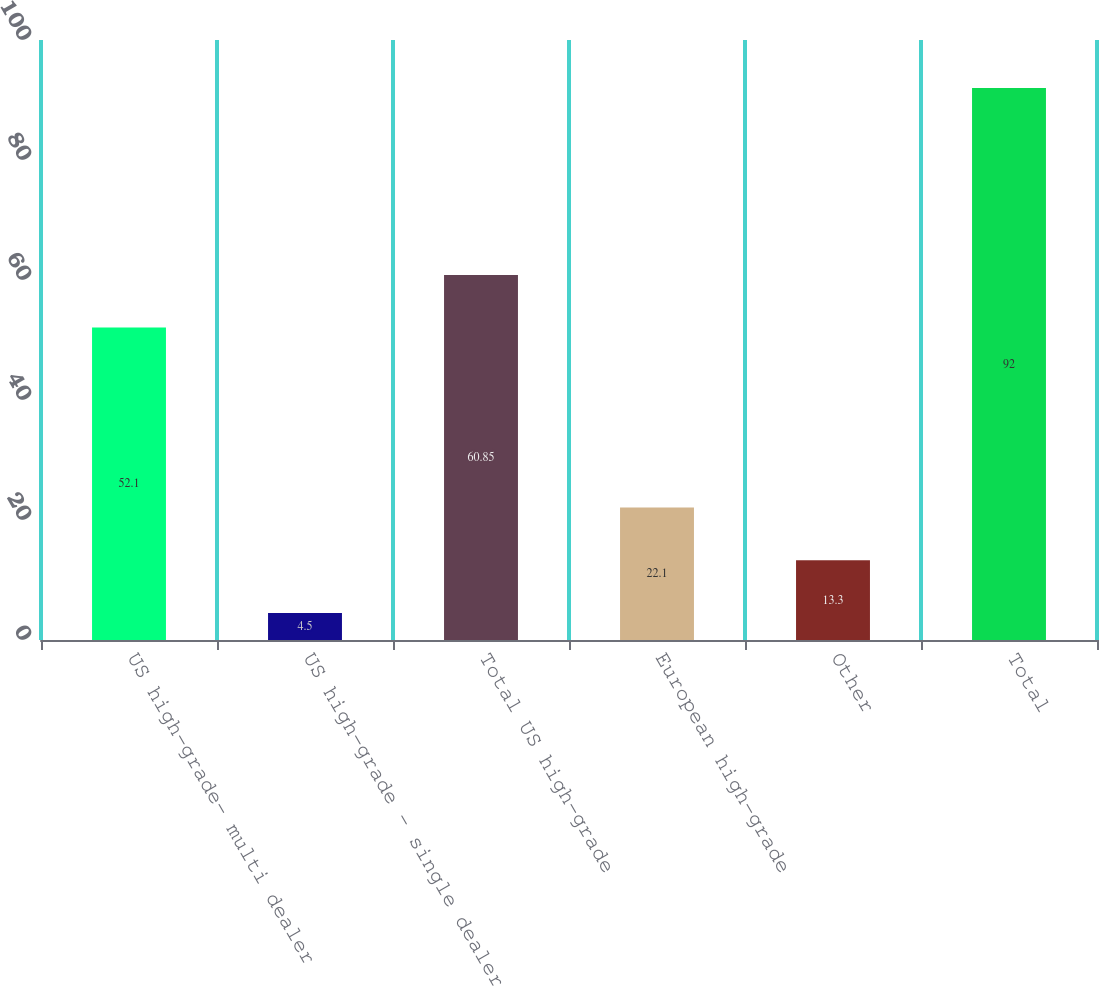Convert chart. <chart><loc_0><loc_0><loc_500><loc_500><bar_chart><fcel>US high-grade- multi dealer<fcel>US high-grade - single dealer<fcel>Total US high-grade<fcel>European high-grade<fcel>Other<fcel>Total<nl><fcel>52.1<fcel>4.5<fcel>60.85<fcel>22.1<fcel>13.3<fcel>92<nl></chart> 